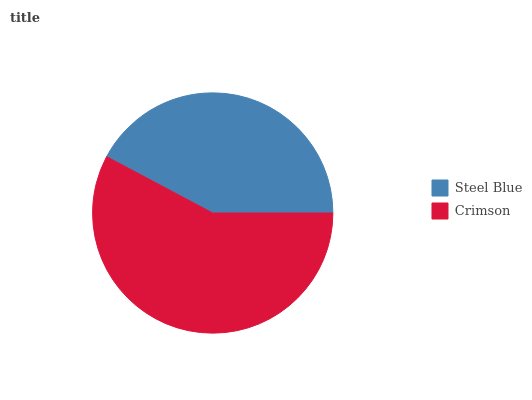Is Steel Blue the minimum?
Answer yes or no. Yes. Is Crimson the maximum?
Answer yes or no. Yes. Is Crimson the minimum?
Answer yes or no. No. Is Crimson greater than Steel Blue?
Answer yes or no. Yes. Is Steel Blue less than Crimson?
Answer yes or no. Yes. Is Steel Blue greater than Crimson?
Answer yes or no. No. Is Crimson less than Steel Blue?
Answer yes or no. No. Is Crimson the high median?
Answer yes or no. Yes. Is Steel Blue the low median?
Answer yes or no. Yes. Is Steel Blue the high median?
Answer yes or no. No. Is Crimson the low median?
Answer yes or no. No. 